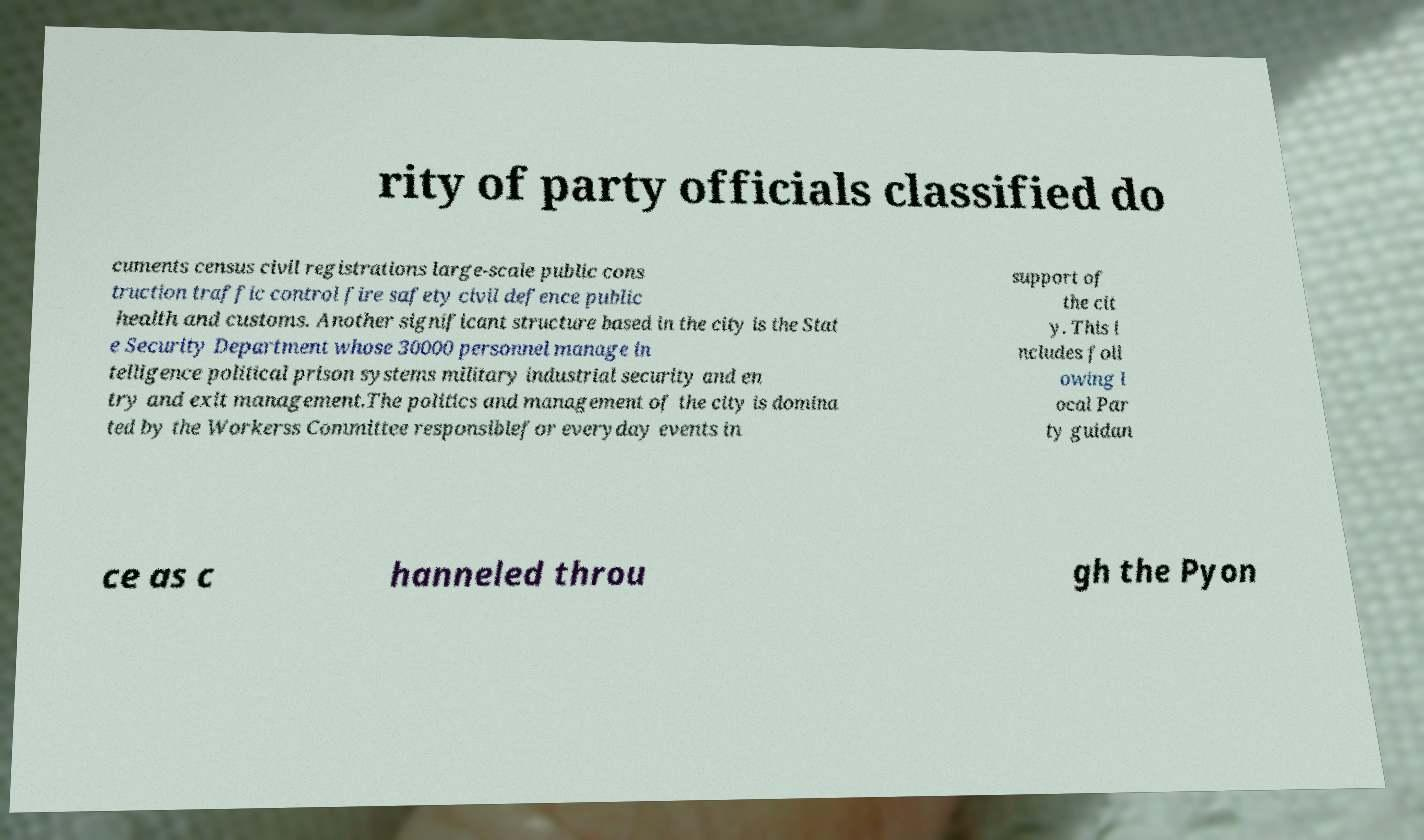Please identify and transcribe the text found in this image. rity of party officials classified do cuments census civil registrations large-scale public cons truction traffic control fire safety civil defence public health and customs. Another significant structure based in the city is the Stat e Security Department whose 30000 personnel manage in telligence political prison systems military industrial security and en try and exit management.The politics and management of the city is domina ted by the Workerss Committee responsiblefor everyday events in support of the cit y. This i ncludes foll owing l ocal Par ty guidan ce as c hanneled throu gh the Pyon 